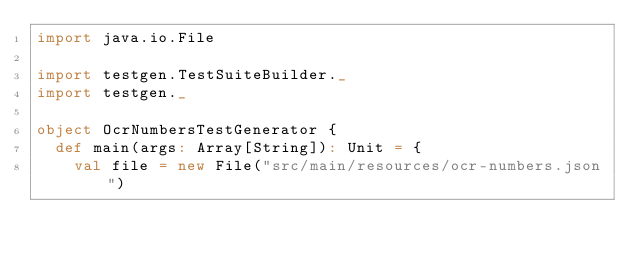Convert code to text. <code><loc_0><loc_0><loc_500><loc_500><_Scala_>import java.io.File

import testgen.TestSuiteBuilder._
import testgen._

object OcrNumbersTestGenerator {
  def main(args: Array[String]): Unit = {
    val file = new File("src/main/resources/ocr-numbers.json")
</code> 